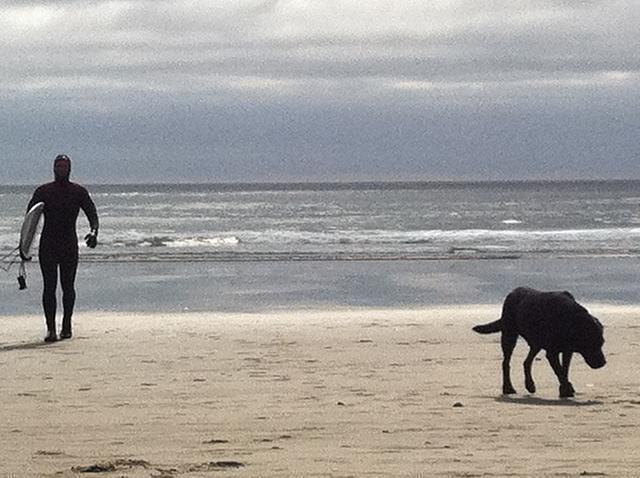Who owns this dog?
Choose the correct response and explain in the format: 'Answer: answer
Rationale: rationale.'
Options: Hippies, vagabond, police, surfer. Answer: surfer.
Rationale: The guy in the wet suit owns the dog. dogs aren't allowed to roam on the beach without their owners. 